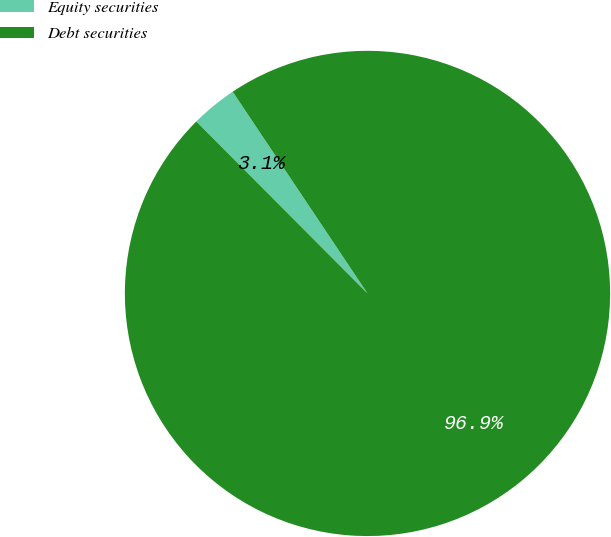Convert chart. <chart><loc_0><loc_0><loc_500><loc_500><pie_chart><fcel>Equity securities<fcel>Debt securities<nl><fcel>3.09%<fcel>96.91%<nl></chart> 